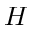Convert formula to latex. <formula><loc_0><loc_0><loc_500><loc_500>H</formula> 